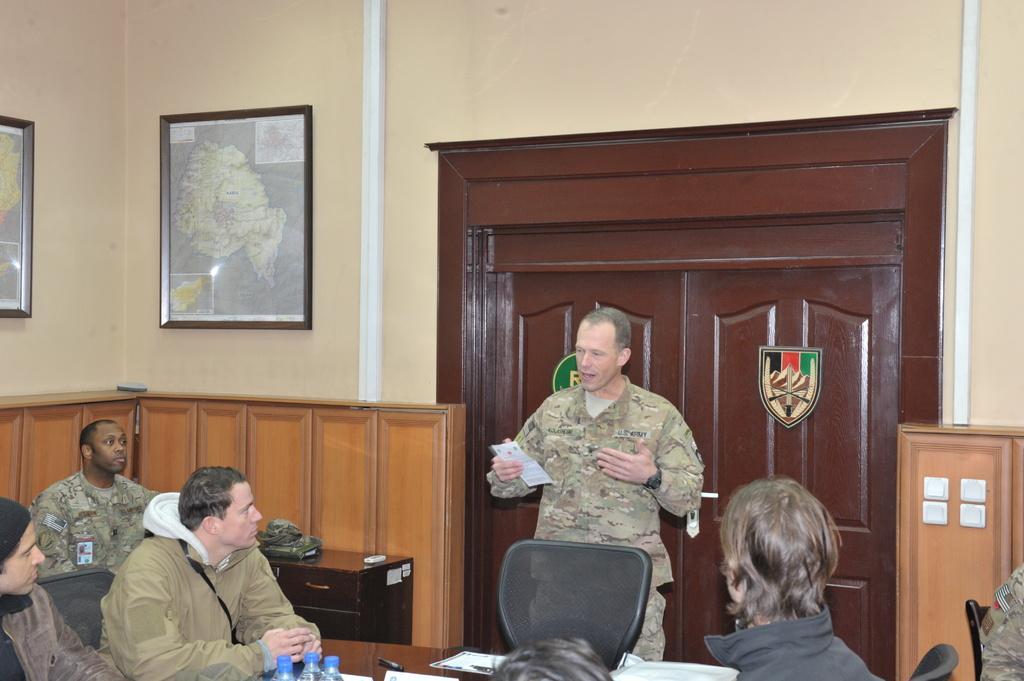Could you give a brief overview of what you see in this image? Here we can see a group of Army people sitting on chairs with a table in front of them and in front of them there is another army man who is speaking something to them and behind him we can see a door and there are portraits present on the walls 